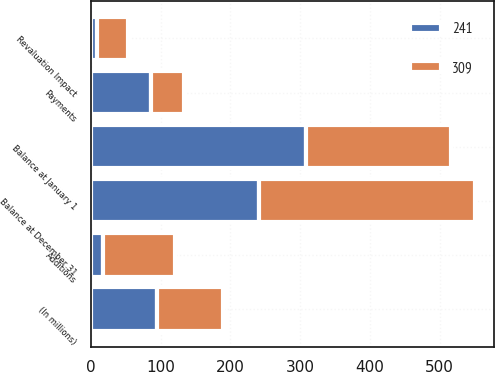<chart> <loc_0><loc_0><loc_500><loc_500><stacked_bar_chart><ecel><fcel>(In millions)<fcel>Balance at January 1<fcel>Additions<fcel>Payments<fcel>Revaluation Impact<fcel>Balance at December 31<nl><fcel>241<fcel>95<fcel>309<fcel>17<fcel>86<fcel>9<fcel>241<nl><fcel>309<fcel>95<fcel>207<fcel>104<fcel>47<fcel>45<fcel>309<nl></chart> 